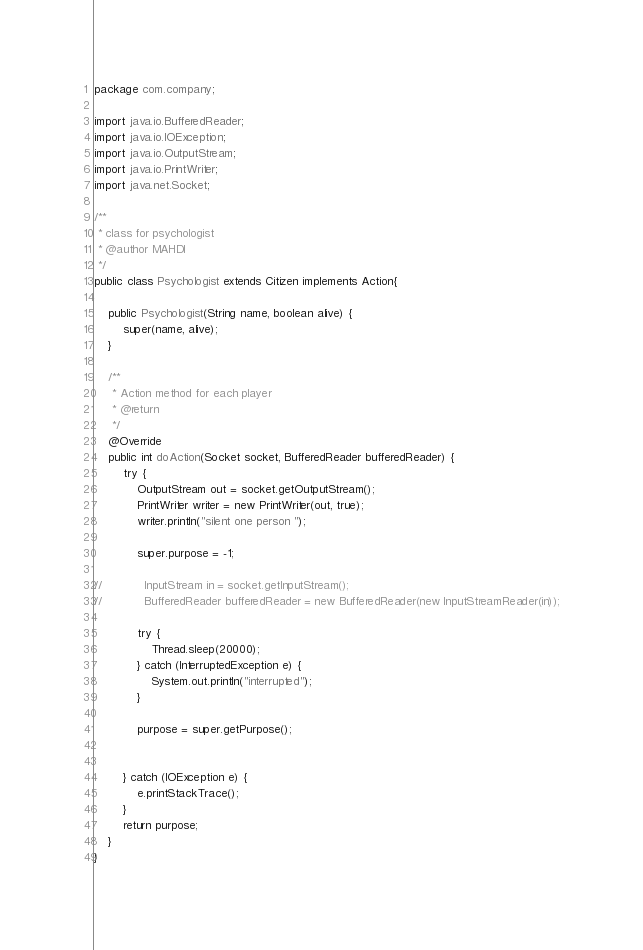Convert code to text. <code><loc_0><loc_0><loc_500><loc_500><_Java_>package com.company;

import java.io.BufferedReader;
import java.io.IOException;
import java.io.OutputStream;
import java.io.PrintWriter;
import java.net.Socket;

/**
 * class for psychologist
 * @author MAHDI
 */
public class Psychologist extends Citizen implements Action{

    public Psychologist(String name, boolean alive) {
        super(name, alive);
    }

    /**
     * Action method for each player
     * @return
     */
    @Override
    public int doAction(Socket socket, BufferedReader bufferedReader) {
        try {
            OutputStream out = socket.getOutputStream();
            PrintWriter writer = new PrintWriter(out, true);
            writer.println("silent one person ");

            super.purpose = -1;

//            InputStream in = socket.getInputStream();
//            BufferedReader bufferedReader = new BufferedReader(new InputStreamReader(in));

            try {
                Thread.sleep(20000);
            } catch (InterruptedException e) {
                System.out.println("interrupted");
            }

            purpose = super.getPurpose();


        } catch (IOException e) {
            e.printStackTrace();
        }
        return purpose;
    }
}
</code> 